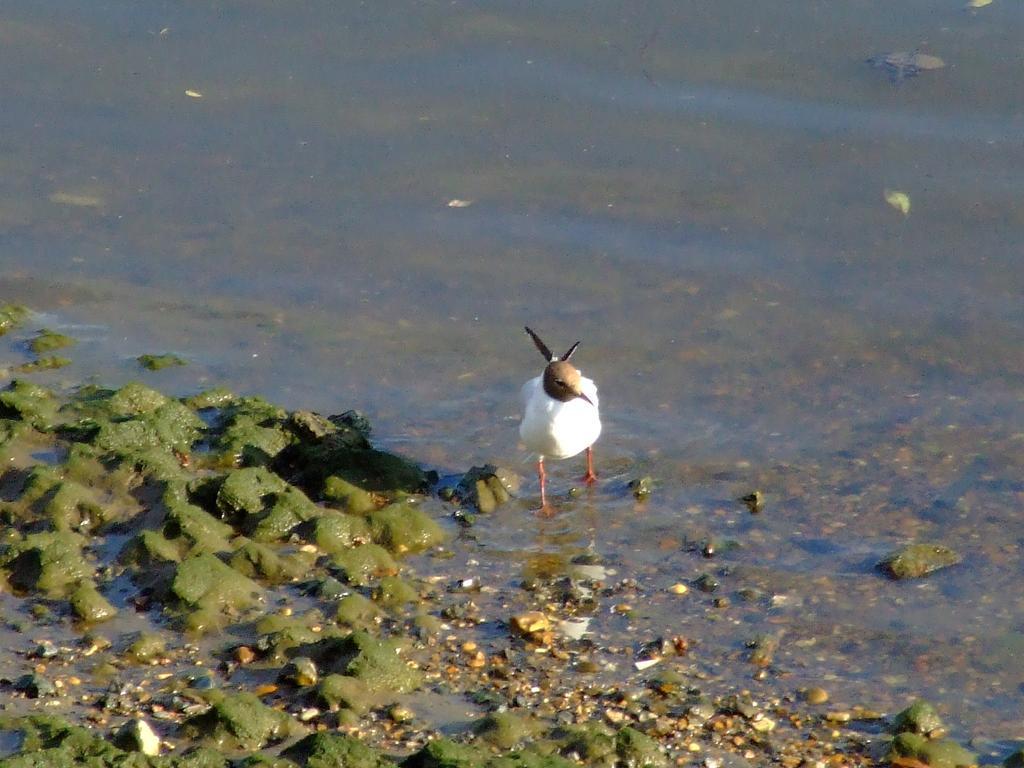In one or two sentences, can you explain what this image depicts? In this picture there is a bird in the center of the image and there is water around the area of the image, there is algae on the left side of the image. 